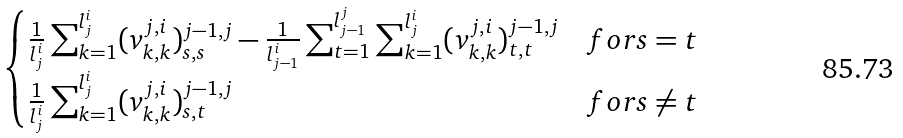Convert formula to latex. <formula><loc_0><loc_0><loc_500><loc_500>\begin{cases} \frac { 1 } { l _ { j } ^ { i } } \sum _ { k = 1 } ^ { l _ { j } ^ { i } } ( v ^ { j , i } _ { k , k } ) ^ { j - 1 , j } _ { s , s } - \frac { 1 } { l _ { j - 1 } ^ { i } } \sum _ { t = 1 } ^ { l _ { j - 1 } ^ { j } } \sum _ { k = 1 } ^ { l _ { j } ^ { i } } ( v ^ { j , i } _ { k , k } ) ^ { j - 1 , j } _ { t , t } & f o r s = t \\ \frac { 1 } { l _ { j } ^ { i } } \sum _ { k = 1 } ^ { l _ { j } ^ { i } } ( v ^ { j , i } _ { k , k } ) ^ { j - 1 , j } _ { s , t } & f o r s \neq t \end{cases}</formula> 